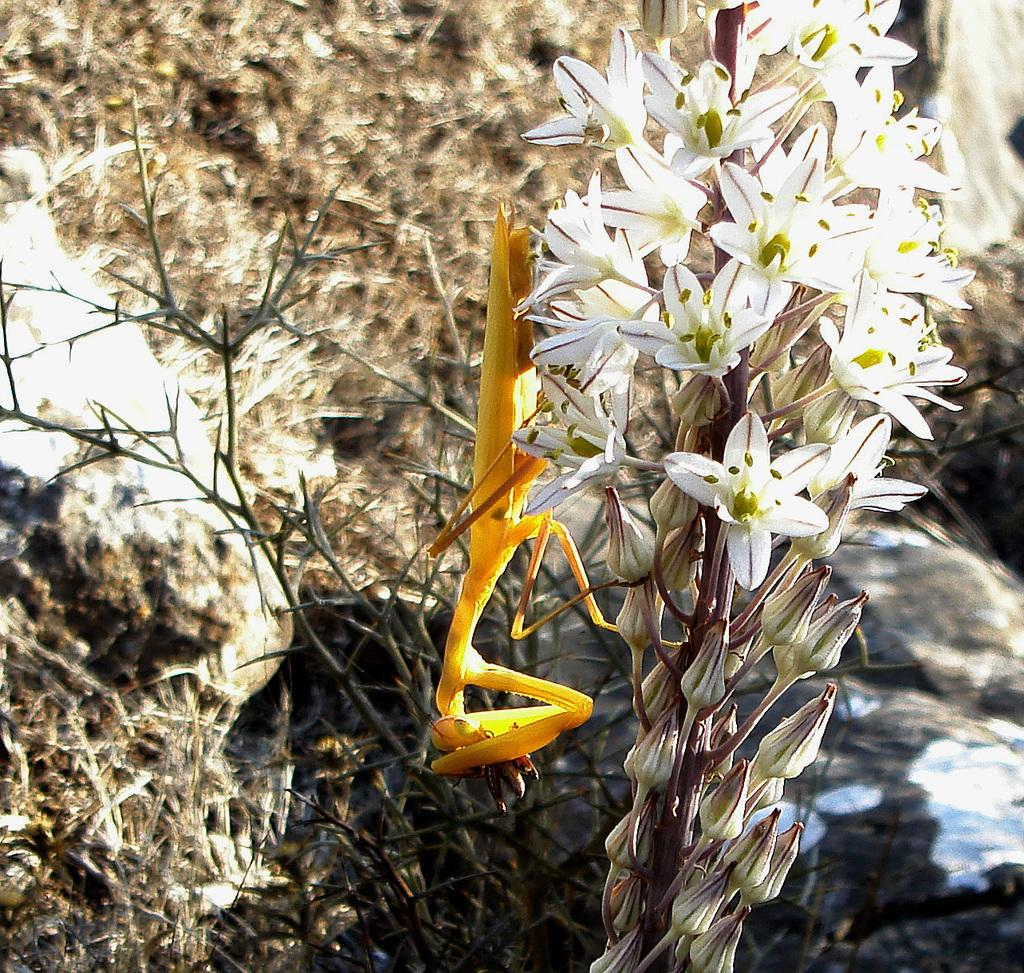What type of insect is in the image? There is a yellow grasshopper in the image. What is the grasshopper sitting on? The grasshopper is on white flowers. Are there any unopened flowers visible in the image? Yes, there are buds in the image. What can be seen in the background of the image? There are plants in the background of the image. What type of store is visible in the image? There is no store present in the image; it features a yellow grasshopper on white flowers with buds and plants in the background. What date is marked on the calendar in the image? There is no calendar present in the image. 